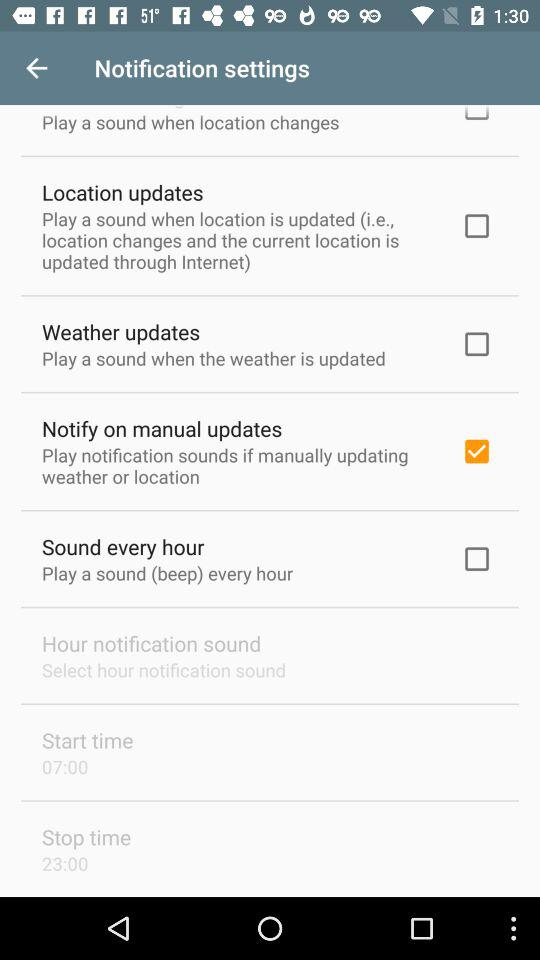What is the selected stop time? The selected stop time is 23:00. 